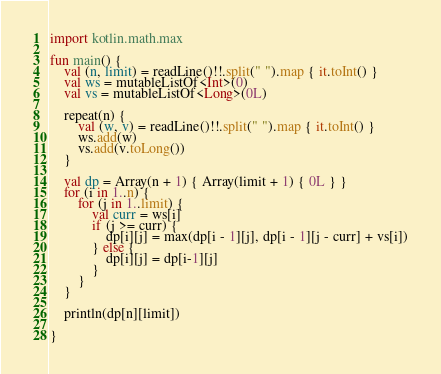<code> <loc_0><loc_0><loc_500><loc_500><_Kotlin_>import kotlin.math.max

fun main() {
    val (n, limit) = readLine()!!.split(" ").map { it.toInt() }
    val ws = mutableListOf<Int>(0)
    val vs = mutableListOf<Long>(0L)

    repeat(n) {
        val (w, v) = readLine()!!.split(" ").map { it.toInt() }
        ws.add(w)
        vs.add(v.toLong())
    }

    val dp = Array(n + 1) { Array(limit + 1) { 0L } }
    for (i in 1..n) {
        for (j in 1..limit) {
            val curr = ws[i]
            if (j >= curr) {
                dp[i][j] = max(dp[i - 1][j], dp[i - 1][j - curr] + vs[i])
            } else {
                dp[i][j] = dp[i-1][j]
            }
        }
    }

    println(dp[n][limit])

}</code> 